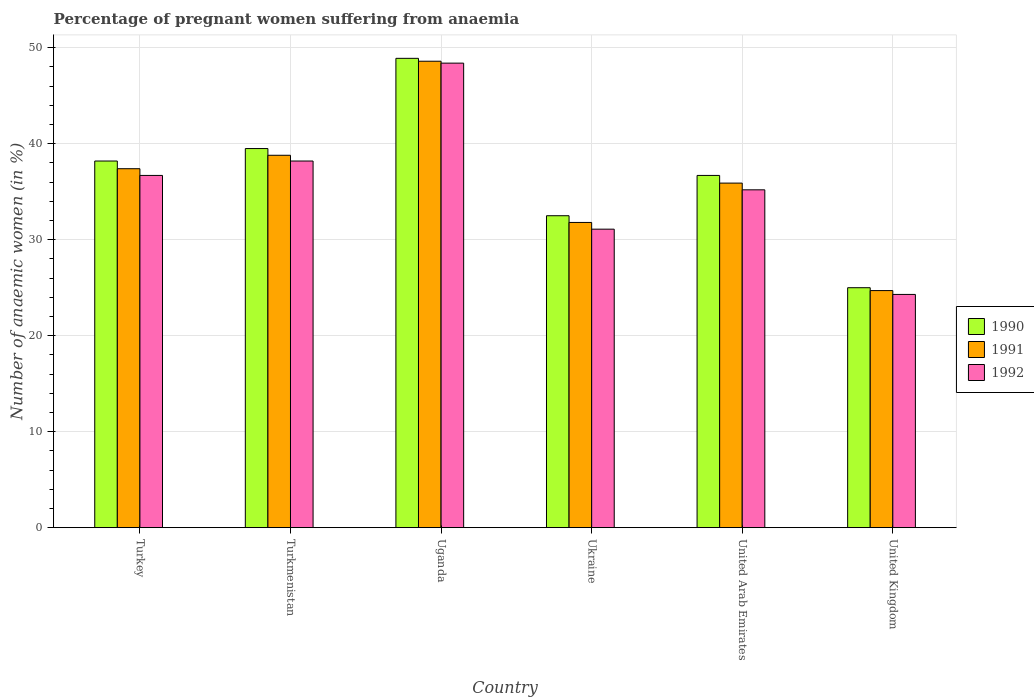How many different coloured bars are there?
Offer a very short reply. 3. How many groups of bars are there?
Provide a succinct answer. 6. Are the number of bars per tick equal to the number of legend labels?
Offer a very short reply. Yes. How many bars are there on the 1st tick from the right?
Provide a succinct answer. 3. What is the label of the 3rd group of bars from the left?
Your response must be concise. Uganda. In how many cases, is the number of bars for a given country not equal to the number of legend labels?
Your response must be concise. 0. What is the number of anaemic women in 1992 in Ukraine?
Provide a short and direct response. 31.1. Across all countries, what is the maximum number of anaemic women in 1991?
Ensure brevity in your answer.  48.6. Across all countries, what is the minimum number of anaemic women in 1991?
Offer a terse response. 24.7. In which country was the number of anaemic women in 1991 maximum?
Offer a very short reply. Uganda. What is the total number of anaemic women in 1990 in the graph?
Offer a terse response. 220.8. What is the difference between the number of anaemic women in 1992 in Turkmenistan and that in Ukraine?
Give a very brief answer. 7.1. What is the difference between the number of anaemic women in 1990 in Turkmenistan and the number of anaemic women in 1991 in Ukraine?
Give a very brief answer. 7.7. What is the average number of anaemic women in 1990 per country?
Your answer should be very brief. 36.8. In how many countries, is the number of anaemic women in 1992 greater than 8 %?
Your answer should be compact. 6. What is the ratio of the number of anaemic women in 1991 in Turkmenistan to that in United Arab Emirates?
Your answer should be compact. 1.08. What is the difference between the highest and the second highest number of anaemic women in 1990?
Give a very brief answer. 10.7. What is the difference between the highest and the lowest number of anaemic women in 1992?
Your answer should be compact. 24.1. In how many countries, is the number of anaemic women in 1990 greater than the average number of anaemic women in 1990 taken over all countries?
Keep it short and to the point. 3. What does the 3rd bar from the left in Turkmenistan represents?
Your answer should be very brief. 1992. How many bars are there?
Your response must be concise. 18. Are all the bars in the graph horizontal?
Offer a very short reply. No. How many countries are there in the graph?
Offer a terse response. 6. What is the difference between two consecutive major ticks on the Y-axis?
Your answer should be compact. 10. Are the values on the major ticks of Y-axis written in scientific E-notation?
Ensure brevity in your answer.  No. How many legend labels are there?
Provide a succinct answer. 3. How are the legend labels stacked?
Your response must be concise. Vertical. What is the title of the graph?
Provide a succinct answer. Percentage of pregnant women suffering from anaemia. Does "1967" appear as one of the legend labels in the graph?
Provide a short and direct response. No. What is the label or title of the X-axis?
Offer a terse response. Country. What is the label or title of the Y-axis?
Your answer should be very brief. Number of anaemic women (in %). What is the Number of anaemic women (in %) of 1990 in Turkey?
Your response must be concise. 38.2. What is the Number of anaemic women (in %) in 1991 in Turkey?
Offer a very short reply. 37.4. What is the Number of anaemic women (in %) in 1992 in Turkey?
Offer a very short reply. 36.7. What is the Number of anaemic women (in %) in 1990 in Turkmenistan?
Your response must be concise. 39.5. What is the Number of anaemic women (in %) in 1991 in Turkmenistan?
Ensure brevity in your answer.  38.8. What is the Number of anaemic women (in %) of 1992 in Turkmenistan?
Offer a very short reply. 38.2. What is the Number of anaemic women (in %) in 1990 in Uganda?
Keep it short and to the point. 48.9. What is the Number of anaemic women (in %) in 1991 in Uganda?
Provide a succinct answer. 48.6. What is the Number of anaemic women (in %) in 1992 in Uganda?
Keep it short and to the point. 48.4. What is the Number of anaemic women (in %) in 1990 in Ukraine?
Provide a short and direct response. 32.5. What is the Number of anaemic women (in %) of 1991 in Ukraine?
Make the answer very short. 31.8. What is the Number of anaemic women (in %) of 1992 in Ukraine?
Your answer should be very brief. 31.1. What is the Number of anaemic women (in %) in 1990 in United Arab Emirates?
Ensure brevity in your answer.  36.7. What is the Number of anaemic women (in %) of 1991 in United Arab Emirates?
Give a very brief answer. 35.9. What is the Number of anaemic women (in %) in 1992 in United Arab Emirates?
Your response must be concise. 35.2. What is the Number of anaemic women (in %) in 1990 in United Kingdom?
Your answer should be very brief. 25. What is the Number of anaemic women (in %) in 1991 in United Kingdom?
Keep it short and to the point. 24.7. What is the Number of anaemic women (in %) in 1992 in United Kingdom?
Your answer should be very brief. 24.3. Across all countries, what is the maximum Number of anaemic women (in %) in 1990?
Give a very brief answer. 48.9. Across all countries, what is the maximum Number of anaemic women (in %) of 1991?
Your answer should be compact. 48.6. Across all countries, what is the maximum Number of anaemic women (in %) of 1992?
Your answer should be very brief. 48.4. Across all countries, what is the minimum Number of anaemic women (in %) of 1991?
Your answer should be very brief. 24.7. Across all countries, what is the minimum Number of anaemic women (in %) of 1992?
Keep it short and to the point. 24.3. What is the total Number of anaemic women (in %) of 1990 in the graph?
Your answer should be compact. 220.8. What is the total Number of anaemic women (in %) in 1991 in the graph?
Keep it short and to the point. 217.2. What is the total Number of anaemic women (in %) of 1992 in the graph?
Provide a succinct answer. 213.9. What is the difference between the Number of anaemic women (in %) in 1990 in Turkey and that in Turkmenistan?
Provide a short and direct response. -1.3. What is the difference between the Number of anaemic women (in %) of 1990 in Turkey and that in Uganda?
Ensure brevity in your answer.  -10.7. What is the difference between the Number of anaemic women (in %) in 1991 in Turkey and that in Uganda?
Ensure brevity in your answer.  -11.2. What is the difference between the Number of anaemic women (in %) of 1992 in Turkey and that in Uganda?
Your answer should be very brief. -11.7. What is the difference between the Number of anaemic women (in %) in 1990 in Turkey and that in Ukraine?
Make the answer very short. 5.7. What is the difference between the Number of anaemic women (in %) of 1991 in Turkey and that in Ukraine?
Offer a terse response. 5.6. What is the difference between the Number of anaemic women (in %) in 1992 in Turkey and that in Ukraine?
Provide a short and direct response. 5.6. What is the difference between the Number of anaemic women (in %) of 1990 in Turkey and that in United Arab Emirates?
Your response must be concise. 1.5. What is the difference between the Number of anaemic women (in %) of 1992 in Turkey and that in United Arab Emirates?
Give a very brief answer. 1.5. What is the difference between the Number of anaemic women (in %) of 1990 in Turkey and that in United Kingdom?
Your response must be concise. 13.2. What is the difference between the Number of anaemic women (in %) in 1991 in Turkey and that in United Kingdom?
Your answer should be compact. 12.7. What is the difference between the Number of anaemic women (in %) of 1992 in Turkey and that in United Kingdom?
Give a very brief answer. 12.4. What is the difference between the Number of anaemic women (in %) in 1991 in Turkmenistan and that in Uganda?
Keep it short and to the point. -9.8. What is the difference between the Number of anaemic women (in %) of 1992 in Turkmenistan and that in Uganda?
Provide a short and direct response. -10.2. What is the difference between the Number of anaemic women (in %) in 1991 in Turkmenistan and that in United Arab Emirates?
Offer a terse response. 2.9. What is the difference between the Number of anaemic women (in %) in 1992 in Turkmenistan and that in United Arab Emirates?
Keep it short and to the point. 3. What is the difference between the Number of anaemic women (in %) in 1991 in Turkmenistan and that in United Kingdom?
Make the answer very short. 14.1. What is the difference between the Number of anaemic women (in %) of 1992 in Uganda and that in Ukraine?
Ensure brevity in your answer.  17.3. What is the difference between the Number of anaemic women (in %) in 1992 in Uganda and that in United Arab Emirates?
Offer a terse response. 13.2. What is the difference between the Number of anaemic women (in %) of 1990 in Uganda and that in United Kingdom?
Offer a terse response. 23.9. What is the difference between the Number of anaemic women (in %) in 1991 in Uganda and that in United Kingdom?
Give a very brief answer. 23.9. What is the difference between the Number of anaemic women (in %) of 1992 in Uganda and that in United Kingdom?
Your answer should be very brief. 24.1. What is the difference between the Number of anaemic women (in %) of 1990 in Ukraine and that in United Arab Emirates?
Keep it short and to the point. -4.2. What is the difference between the Number of anaemic women (in %) of 1990 in Ukraine and that in United Kingdom?
Give a very brief answer. 7.5. What is the difference between the Number of anaemic women (in %) in 1991 in Ukraine and that in United Kingdom?
Provide a short and direct response. 7.1. What is the difference between the Number of anaemic women (in %) of 1992 in Ukraine and that in United Kingdom?
Provide a short and direct response. 6.8. What is the difference between the Number of anaemic women (in %) of 1991 in United Arab Emirates and that in United Kingdom?
Offer a very short reply. 11.2. What is the difference between the Number of anaemic women (in %) in 1991 in Turkey and the Number of anaemic women (in %) in 1992 in Uganda?
Your response must be concise. -11. What is the difference between the Number of anaemic women (in %) in 1990 in Turkey and the Number of anaemic women (in %) in 1991 in Ukraine?
Your answer should be compact. 6.4. What is the difference between the Number of anaemic women (in %) in 1990 in Turkey and the Number of anaemic women (in %) in 1992 in Ukraine?
Provide a succinct answer. 7.1. What is the difference between the Number of anaemic women (in %) in 1990 in Turkey and the Number of anaemic women (in %) in 1991 in United Arab Emirates?
Provide a short and direct response. 2.3. What is the difference between the Number of anaemic women (in %) of 1991 in Turkey and the Number of anaemic women (in %) of 1992 in United Arab Emirates?
Provide a short and direct response. 2.2. What is the difference between the Number of anaemic women (in %) in 1991 in Turkmenistan and the Number of anaemic women (in %) in 1992 in Uganda?
Your answer should be compact. -9.6. What is the difference between the Number of anaemic women (in %) of 1990 in Turkmenistan and the Number of anaemic women (in %) of 1991 in Ukraine?
Give a very brief answer. 7.7. What is the difference between the Number of anaemic women (in %) in 1991 in Turkmenistan and the Number of anaemic women (in %) in 1992 in Ukraine?
Your answer should be compact. 7.7. What is the difference between the Number of anaemic women (in %) of 1990 in Turkmenistan and the Number of anaemic women (in %) of 1992 in United Kingdom?
Ensure brevity in your answer.  15.2. What is the difference between the Number of anaemic women (in %) in 1990 in Uganda and the Number of anaemic women (in %) in 1991 in Ukraine?
Your response must be concise. 17.1. What is the difference between the Number of anaemic women (in %) of 1991 in Uganda and the Number of anaemic women (in %) of 1992 in Ukraine?
Your answer should be compact. 17.5. What is the difference between the Number of anaemic women (in %) of 1991 in Uganda and the Number of anaemic women (in %) of 1992 in United Arab Emirates?
Offer a terse response. 13.4. What is the difference between the Number of anaemic women (in %) of 1990 in Uganda and the Number of anaemic women (in %) of 1991 in United Kingdom?
Offer a terse response. 24.2. What is the difference between the Number of anaemic women (in %) in 1990 in Uganda and the Number of anaemic women (in %) in 1992 in United Kingdom?
Ensure brevity in your answer.  24.6. What is the difference between the Number of anaemic women (in %) in 1991 in Uganda and the Number of anaemic women (in %) in 1992 in United Kingdom?
Offer a very short reply. 24.3. What is the difference between the Number of anaemic women (in %) in 1990 in Ukraine and the Number of anaemic women (in %) in 1991 in United Arab Emirates?
Ensure brevity in your answer.  -3.4. What is the difference between the Number of anaemic women (in %) in 1991 in Ukraine and the Number of anaemic women (in %) in 1992 in United Arab Emirates?
Make the answer very short. -3.4. What is the difference between the Number of anaemic women (in %) in 1990 in Ukraine and the Number of anaemic women (in %) in 1992 in United Kingdom?
Your answer should be very brief. 8.2. What is the difference between the Number of anaemic women (in %) of 1990 in United Arab Emirates and the Number of anaemic women (in %) of 1991 in United Kingdom?
Give a very brief answer. 12. What is the difference between the Number of anaemic women (in %) of 1990 in United Arab Emirates and the Number of anaemic women (in %) of 1992 in United Kingdom?
Provide a succinct answer. 12.4. What is the average Number of anaemic women (in %) in 1990 per country?
Keep it short and to the point. 36.8. What is the average Number of anaemic women (in %) of 1991 per country?
Your answer should be compact. 36.2. What is the average Number of anaemic women (in %) in 1992 per country?
Keep it short and to the point. 35.65. What is the difference between the Number of anaemic women (in %) in 1990 and Number of anaemic women (in %) in 1991 in Turkey?
Provide a succinct answer. 0.8. What is the difference between the Number of anaemic women (in %) in 1990 and Number of anaemic women (in %) in 1992 in Turkey?
Your answer should be very brief. 1.5. What is the difference between the Number of anaemic women (in %) in 1991 and Number of anaemic women (in %) in 1992 in Turkey?
Your response must be concise. 0.7. What is the difference between the Number of anaemic women (in %) of 1990 and Number of anaemic women (in %) of 1991 in Turkmenistan?
Your answer should be very brief. 0.7. What is the difference between the Number of anaemic women (in %) of 1991 and Number of anaemic women (in %) of 1992 in Turkmenistan?
Your response must be concise. 0.6. What is the difference between the Number of anaemic women (in %) in 1990 and Number of anaemic women (in %) in 1991 in Uganda?
Offer a very short reply. 0.3. What is the difference between the Number of anaemic women (in %) in 1990 and Number of anaemic women (in %) in 1992 in Uganda?
Your answer should be compact. 0.5. What is the difference between the Number of anaemic women (in %) in 1991 and Number of anaemic women (in %) in 1992 in Ukraine?
Your answer should be very brief. 0.7. What is the difference between the Number of anaemic women (in %) of 1990 and Number of anaemic women (in %) of 1991 in United Arab Emirates?
Provide a short and direct response. 0.8. What is the difference between the Number of anaemic women (in %) in 1991 and Number of anaemic women (in %) in 1992 in United Kingdom?
Offer a terse response. 0.4. What is the ratio of the Number of anaemic women (in %) of 1990 in Turkey to that in Turkmenistan?
Offer a terse response. 0.97. What is the ratio of the Number of anaemic women (in %) of 1991 in Turkey to that in Turkmenistan?
Provide a succinct answer. 0.96. What is the ratio of the Number of anaemic women (in %) in 1992 in Turkey to that in Turkmenistan?
Your answer should be very brief. 0.96. What is the ratio of the Number of anaemic women (in %) in 1990 in Turkey to that in Uganda?
Ensure brevity in your answer.  0.78. What is the ratio of the Number of anaemic women (in %) of 1991 in Turkey to that in Uganda?
Make the answer very short. 0.77. What is the ratio of the Number of anaemic women (in %) of 1992 in Turkey to that in Uganda?
Give a very brief answer. 0.76. What is the ratio of the Number of anaemic women (in %) of 1990 in Turkey to that in Ukraine?
Give a very brief answer. 1.18. What is the ratio of the Number of anaemic women (in %) in 1991 in Turkey to that in Ukraine?
Your response must be concise. 1.18. What is the ratio of the Number of anaemic women (in %) of 1992 in Turkey to that in Ukraine?
Keep it short and to the point. 1.18. What is the ratio of the Number of anaemic women (in %) in 1990 in Turkey to that in United Arab Emirates?
Your response must be concise. 1.04. What is the ratio of the Number of anaemic women (in %) in 1991 in Turkey to that in United Arab Emirates?
Ensure brevity in your answer.  1.04. What is the ratio of the Number of anaemic women (in %) of 1992 in Turkey to that in United Arab Emirates?
Keep it short and to the point. 1.04. What is the ratio of the Number of anaemic women (in %) in 1990 in Turkey to that in United Kingdom?
Offer a very short reply. 1.53. What is the ratio of the Number of anaemic women (in %) in 1991 in Turkey to that in United Kingdom?
Provide a succinct answer. 1.51. What is the ratio of the Number of anaemic women (in %) in 1992 in Turkey to that in United Kingdom?
Keep it short and to the point. 1.51. What is the ratio of the Number of anaemic women (in %) in 1990 in Turkmenistan to that in Uganda?
Your answer should be very brief. 0.81. What is the ratio of the Number of anaemic women (in %) in 1991 in Turkmenistan to that in Uganda?
Your response must be concise. 0.8. What is the ratio of the Number of anaemic women (in %) in 1992 in Turkmenistan to that in Uganda?
Ensure brevity in your answer.  0.79. What is the ratio of the Number of anaemic women (in %) in 1990 in Turkmenistan to that in Ukraine?
Provide a short and direct response. 1.22. What is the ratio of the Number of anaemic women (in %) of 1991 in Turkmenistan to that in Ukraine?
Your response must be concise. 1.22. What is the ratio of the Number of anaemic women (in %) in 1992 in Turkmenistan to that in Ukraine?
Your answer should be very brief. 1.23. What is the ratio of the Number of anaemic women (in %) in 1990 in Turkmenistan to that in United Arab Emirates?
Your answer should be compact. 1.08. What is the ratio of the Number of anaemic women (in %) in 1991 in Turkmenistan to that in United Arab Emirates?
Keep it short and to the point. 1.08. What is the ratio of the Number of anaemic women (in %) in 1992 in Turkmenistan to that in United Arab Emirates?
Keep it short and to the point. 1.09. What is the ratio of the Number of anaemic women (in %) of 1990 in Turkmenistan to that in United Kingdom?
Your response must be concise. 1.58. What is the ratio of the Number of anaemic women (in %) in 1991 in Turkmenistan to that in United Kingdom?
Offer a very short reply. 1.57. What is the ratio of the Number of anaemic women (in %) of 1992 in Turkmenistan to that in United Kingdom?
Give a very brief answer. 1.57. What is the ratio of the Number of anaemic women (in %) of 1990 in Uganda to that in Ukraine?
Provide a short and direct response. 1.5. What is the ratio of the Number of anaemic women (in %) of 1991 in Uganda to that in Ukraine?
Make the answer very short. 1.53. What is the ratio of the Number of anaemic women (in %) of 1992 in Uganda to that in Ukraine?
Give a very brief answer. 1.56. What is the ratio of the Number of anaemic women (in %) in 1990 in Uganda to that in United Arab Emirates?
Keep it short and to the point. 1.33. What is the ratio of the Number of anaemic women (in %) of 1991 in Uganda to that in United Arab Emirates?
Keep it short and to the point. 1.35. What is the ratio of the Number of anaemic women (in %) in 1992 in Uganda to that in United Arab Emirates?
Ensure brevity in your answer.  1.38. What is the ratio of the Number of anaemic women (in %) in 1990 in Uganda to that in United Kingdom?
Provide a succinct answer. 1.96. What is the ratio of the Number of anaemic women (in %) in 1991 in Uganda to that in United Kingdom?
Your answer should be very brief. 1.97. What is the ratio of the Number of anaemic women (in %) in 1992 in Uganda to that in United Kingdom?
Give a very brief answer. 1.99. What is the ratio of the Number of anaemic women (in %) in 1990 in Ukraine to that in United Arab Emirates?
Ensure brevity in your answer.  0.89. What is the ratio of the Number of anaemic women (in %) in 1991 in Ukraine to that in United Arab Emirates?
Provide a succinct answer. 0.89. What is the ratio of the Number of anaemic women (in %) in 1992 in Ukraine to that in United Arab Emirates?
Give a very brief answer. 0.88. What is the ratio of the Number of anaemic women (in %) in 1991 in Ukraine to that in United Kingdom?
Provide a short and direct response. 1.29. What is the ratio of the Number of anaemic women (in %) in 1992 in Ukraine to that in United Kingdom?
Provide a succinct answer. 1.28. What is the ratio of the Number of anaemic women (in %) in 1990 in United Arab Emirates to that in United Kingdom?
Provide a short and direct response. 1.47. What is the ratio of the Number of anaemic women (in %) in 1991 in United Arab Emirates to that in United Kingdom?
Give a very brief answer. 1.45. What is the ratio of the Number of anaemic women (in %) in 1992 in United Arab Emirates to that in United Kingdom?
Provide a succinct answer. 1.45. What is the difference between the highest and the second highest Number of anaemic women (in %) of 1990?
Make the answer very short. 9.4. What is the difference between the highest and the second highest Number of anaemic women (in %) in 1991?
Your answer should be very brief. 9.8. What is the difference between the highest and the lowest Number of anaemic women (in %) in 1990?
Ensure brevity in your answer.  23.9. What is the difference between the highest and the lowest Number of anaemic women (in %) in 1991?
Make the answer very short. 23.9. What is the difference between the highest and the lowest Number of anaemic women (in %) in 1992?
Offer a very short reply. 24.1. 